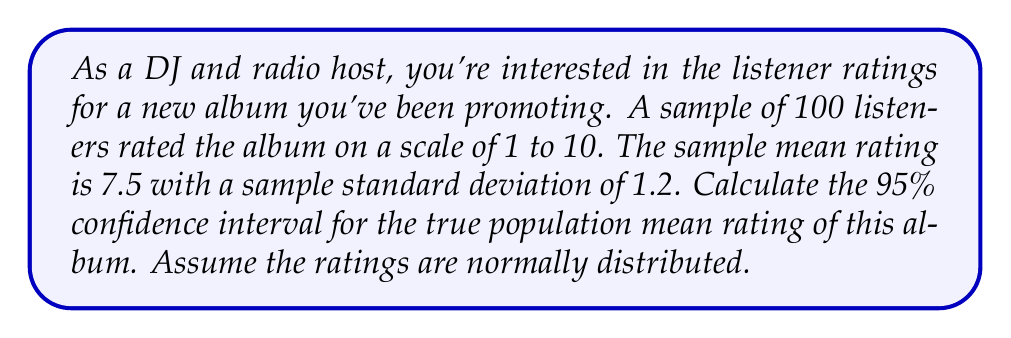Show me your answer to this math problem. To calculate the confidence interval, we'll use the formula:

$$ \text{CI} = \bar{x} \pm t_{\alpha/2} \cdot \frac{s}{\sqrt{n}} $$

Where:
- $\bar{x}$ is the sample mean (7.5)
- $s$ is the sample standard deviation (1.2)
- $n$ is the sample size (100)
- $t_{\alpha/2}$ is the t-value for a 95% confidence interval with 99 degrees of freedom

Steps:
1) For a 95% CI, $\alpha = 0.05$, and $\alpha/2 = 0.025$
2) Degrees of freedom = $n - 1 = 99$
3) From a t-table, $t_{0.025,99} \approx 1.984$

Now, let's calculate the margin of error:

$$ \text{Margin of Error} = t_{\alpha/2} \cdot \frac{s}{\sqrt{n}} = 1.984 \cdot \frac{1.2}{\sqrt{100}} = 1.984 \cdot 0.12 = 0.238 $$

The confidence interval is thus:

$$ 7.5 \pm 0.238 $$

Lower bound: $7.5 - 0.238 = 7.262$
Upper bound: $7.5 + 0.238 = 7.738$
Answer: The 95% confidence interval for the true population mean rating of the album is (7.262, 7.738). 